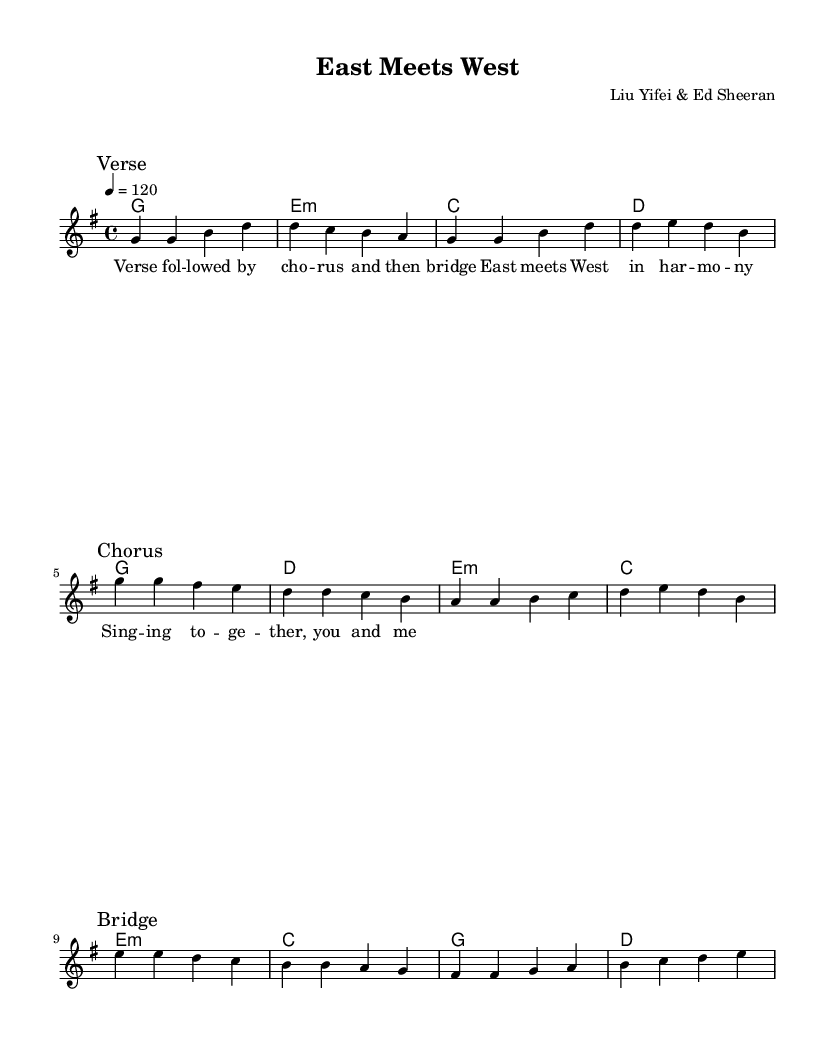What is the key signature of this piece? The key signature indicated in the music is G major, which has one sharp (F#). This is determined by the key signature marking at the beginning of the score.
Answer: G major What is the time signature used in this music? The time signature is 4/4, which is indicated at the beginning of the music. This means there are four beats in each measure, and the quarter note receives one beat.
Answer: 4/4 What is the tempo marking for this piece? The tempo marking is indicated as quarter note equals 120 beats per minute. This gives a moderate pace for the piece, as set at the beginning of the score.
Answer: 120 How many sections are there in the melody? The melody is divided into three distinct sections: Verse, Chorus, and Bridge, as marked within the score. Each section has a different musical theme.
Answer: Three What is the last chord in the bridge section? The last chord in the bridge section is D major, as shown in the harmonies beneath the melody. This concludes that section of the song.
Answer: D What is the lyrical theme of this song? The lyrical theme revolves around the idea of unity and collaboration, as indicated by the line "East meets West in harmony." This reflects a cultural blending of two musical worlds.
Answer: Unity 